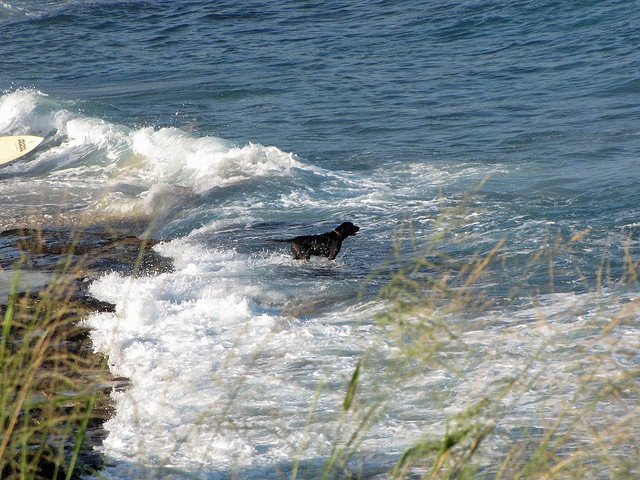Describe the objects in this image and their specific colors. I can see dog in gray and black tones and surfboard in gray, beige, khaki, darkgray, and tan tones in this image. 